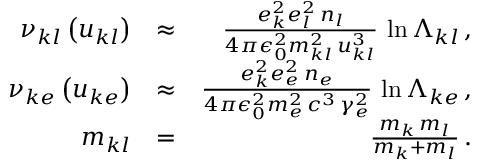<formula> <loc_0><loc_0><loc_500><loc_500>\begin{array} { r l r } { \nu _ { k l } \left ( u _ { k l } \right ) } & { \approx } & { \frac { e _ { k } ^ { 2 } e _ { l } ^ { 2 } \, n _ { l } } { 4 \pi \epsilon _ { 0 } ^ { 2 } m _ { k l } ^ { 2 } \, u _ { k l } ^ { 3 } } \, \ln \Lambda _ { k l } \, , } \\ { \nu _ { k e } \left ( u _ { k e } \right ) } & { \approx } & { \frac { e _ { k } ^ { 2 } e _ { e } ^ { 2 } \, n _ { e } } { 4 \pi \epsilon _ { 0 } ^ { 2 } m _ { e } ^ { 2 } \, c ^ { 3 } \, \gamma _ { e } ^ { 2 } } \, \ln \Lambda _ { k e } \, , } \\ { m _ { k l } } & { = } & { \frac { m _ { k } \, m _ { l } } { m _ { k } + m _ { l } } \, . } \end{array}</formula> 